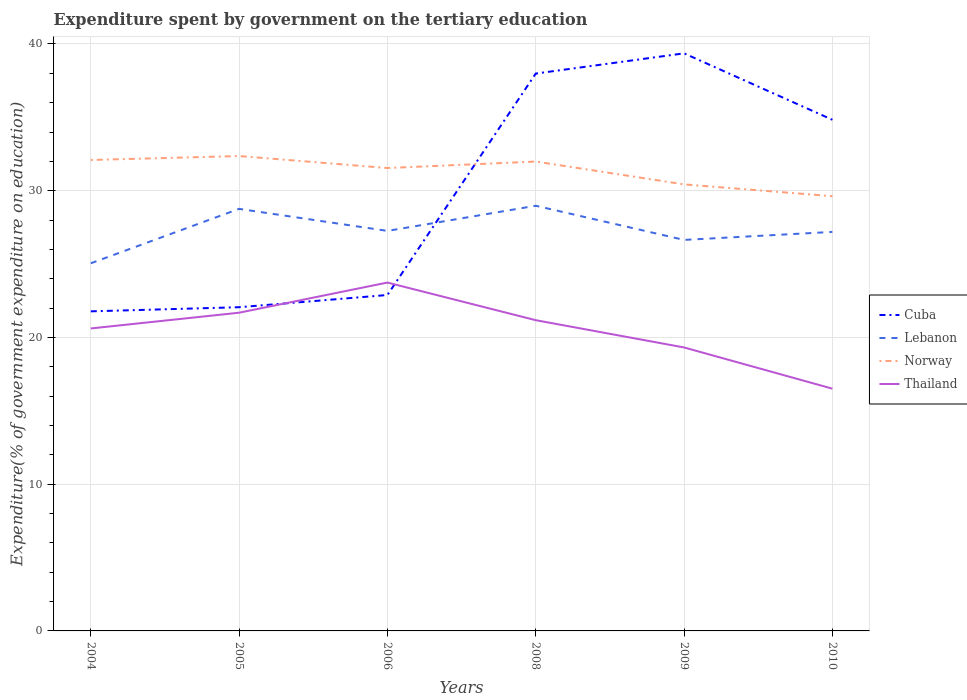Does the line corresponding to Norway intersect with the line corresponding to Cuba?
Ensure brevity in your answer.  Yes. Is the number of lines equal to the number of legend labels?
Keep it short and to the point. Yes. Across all years, what is the maximum expenditure spent by government on the tertiary education in Thailand?
Ensure brevity in your answer.  16.51. In which year was the expenditure spent by government on the tertiary education in Thailand maximum?
Your answer should be compact. 2010. What is the total expenditure spent by government on the tertiary education in Norway in the graph?
Provide a short and direct response. 2.74. What is the difference between the highest and the second highest expenditure spent by government on the tertiary education in Thailand?
Offer a very short reply. 7.23. What is the difference between the highest and the lowest expenditure spent by government on the tertiary education in Cuba?
Give a very brief answer. 3. How many years are there in the graph?
Your answer should be compact. 6. Are the values on the major ticks of Y-axis written in scientific E-notation?
Ensure brevity in your answer.  No. Does the graph contain any zero values?
Offer a terse response. No. Where does the legend appear in the graph?
Make the answer very short. Center right. How many legend labels are there?
Your answer should be compact. 4. How are the legend labels stacked?
Ensure brevity in your answer.  Vertical. What is the title of the graph?
Give a very brief answer. Expenditure spent by government on the tertiary education. What is the label or title of the Y-axis?
Provide a succinct answer. Expenditure(% of government expenditure on education). What is the Expenditure(% of government expenditure on education) of Cuba in 2004?
Keep it short and to the point. 21.78. What is the Expenditure(% of government expenditure on education) of Lebanon in 2004?
Provide a short and direct response. 25.05. What is the Expenditure(% of government expenditure on education) of Norway in 2004?
Provide a short and direct response. 32.09. What is the Expenditure(% of government expenditure on education) of Thailand in 2004?
Provide a short and direct response. 20.61. What is the Expenditure(% of government expenditure on education) in Cuba in 2005?
Your response must be concise. 22.06. What is the Expenditure(% of government expenditure on education) in Lebanon in 2005?
Your answer should be compact. 28.76. What is the Expenditure(% of government expenditure on education) of Norway in 2005?
Your response must be concise. 32.36. What is the Expenditure(% of government expenditure on education) of Thailand in 2005?
Provide a short and direct response. 21.69. What is the Expenditure(% of government expenditure on education) in Cuba in 2006?
Provide a succinct answer. 22.89. What is the Expenditure(% of government expenditure on education) of Lebanon in 2006?
Ensure brevity in your answer.  27.26. What is the Expenditure(% of government expenditure on education) in Norway in 2006?
Offer a terse response. 31.55. What is the Expenditure(% of government expenditure on education) in Thailand in 2006?
Offer a very short reply. 23.74. What is the Expenditure(% of government expenditure on education) in Cuba in 2008?
Your answer should be compact. 37.98. What is the Expenditure(% of government expenditure on education) in Lebanon in 2008?
Your answer should be compact. 28.98. What is the Expenditure(% of government expenditure on education) in Norway in 2008?
Ensure brevity in your answer.  31.99. What is the Expenditure(% of government expenditure on education) of Thailand in 2008?
Your response must be concise. 21.18. What is the Expenditure(% of government expenditure on education) in Cuba in 2009?
Provide a short and direct response. 39.36. What is the Expenditure(% of government expenditure on education) in Lebanon in 2009?
Your response must be concise. 26.65. What is the Expenditure(% of government expenditure on education) of Norway in 2009?
Your answer should be compact. 30.43. What is the Expenditure(% of government expenditure on education) of Thailand in 2009?
Your answer should be very brief. 19.32. What is the Expenditure(% of government expenditure on education) in Cuba in 2010?
Offer a very short reply. 34.83. What is the Expenditure(% of government expenditure on education) in Lebanon in 2010?
Offer a terse response. 27.19. What is the Expenditure(% of government expenditure on education) of Norway in 2010?
Keep it short and to the point. 29.63. What is the Expenditure(% of government expenditure on education) in Thailand in 2010?
Your answer should be compact. 16.51. Across all years, what is the maximum Expenditure(% of government expenditure on education) of Cuba?
Ensure brevity in your answer.  39.36. Across all years, what is the maximum Expenditure(% of government expenditure on education) in Lebanon?
Offer a terse response. 28.98. Across all years, what is the maximum Expenditure(% of government expenditure on education) in Norway?
Make the answer very short. 32.36. Across all years, what is the maximum Expenditure(% of government expenditure on education) in Thailand?
Ensure brevity in your answer.  23.74. Across all years, what is the minimum Expenditure(% of government expenditure on education) of Cuba?
Provide a succinct answer. 21.78. Across all years, what is the minimum Expenditure(% of government expenditure on education) in Lebanon?
Your answer should be compact. 25.05. Across all years, what is the minimum Expenditure(% of government expenditure on education) in Norway?
Your answer should be compact. 29.63. Across all years, what is the minimum Expenditure(% of government expenditure on education) in Thailand?
Provide a short and direct response. 16.51. What is the total Expenditure(% of government expenditure on education) of Cuba in the graph?
Give a very brief answer. 178.91. What is the total Expenditure(% of government expenditure on education) in Lebanon in the graph?
Give a very brief answer. 163.89. What is the total Expenditure(% of government expenditure on education) in Norway in the graph?
Offer a terse response. 188.05. What is the total Expenditure(% of government expenditure on education) in Thailand in the graph?
Offer a very short reply. 123.04. What is the difference between the Expenditure(% of government expenditure on education) of Cuba in 2004 and that in 2005?
Provide a short and direct response. -0.28. What is the difference between the Expenditure(% of government expenditure on education) in Lebanon in 2004 and that in 2005?
Offer a very short reply. -3.71. What is the difference between the Expenditure(% of government expenditure on education) in Norway in 2004 and that in 2005?
Provide a short and direct response. -0.27. What is the difference between the Expenditure(% of government expenditure on education) of Thailand in 2004 and that in 2005?
Provide a short and direct response. -1.07. What is the difference between the Expenditure(% of government expenditure on education) in Cuba in 2004 and that in 2006?
Offer a very short reply. -1.11. What is the difference between the Expenditure(% of government expenditure on education) in Lebanon in 2004 and that in 2006?
Offer a very short reply. -2.21. What is the difference between the Expenditure(% of government expenditure on education) of Norway in 2004 and that in 2006?
Make the answer very short. 0.55. What is the difference between the Expenditure(% of government expenditure on education) in Thailand in 2004 and that in 2006?
Provide a short and direct response. -3.13. What is the difference between the Expenditure(% of government expenditure on education) of Cuba in 2004 and that in 2008?
Ensure brevity in your answer.  -16.21. What is the difference between the Expenditure(% of government expenditure on education) of Lebanon in 2004 and that in 2008?
Give a very brief answer. -3.92. What is the difference between the Expenditure(% of government expenditure on education) of Norway in 2004 and that in 2008?
Provide a short and direct response. 0.11. What is the difference between the Expenditure(% of government expenditure on education) of Thailand in 2004 and that in 2008?
Your answer should be compact. -0.56. What is the difference between the Expenditure(% of government expenditure on education) of Cuba in 2004 and that in 2009?
Your answer should be very brief. -17.58. What is the difference between the Expenditure(% of government expenditure on education) of Lebanon in 2004 and that in 2009?
Offer a very short reply. -1.59. What is the difference between the Expenditure(% of government expenditure on education) of Norway in 2004 and that in 2009?
Offer a terse response. 1.66. What is the difference between the Expenditure(% of government expenditure on education) of Thailand in 2004 and that in 2009?
Your answer should be very brief. 1.29. What is the difference between the Expenditure(% of government expenditure on education) of Cuba in 2004 and that in 2010?
Your answer should be very brief. -13.06. What is the difference between the Expenditure(% of government expenditure on education) of Lebanon in 2004 and that in 2010?
Ensure brevity in your answer.  -2.14. What is the difference between the Expenditure(% of government expenditure on education) in Norway in 2004 and that in 2010?
Keep it short and to the point. 2.47. What is the difference between the Expenditure(% of government expenditure on education) of Thailand in 2004 and that in 2010?
Ensure brevity in your answer.  4.1. What is the difference between the Expenditure(% of government expenditure on education) of Cuba in 2005 and that in 2006?
Offer a very short reply. -0.83. What is the difference between the Expenditure(% of government expenditure on education) in Lebanon in 2005 and that in 2006?
Your answer should be compact. 1.5. What is the difference between the Expenditure(% of government expenditure on education) of Norway in 2005 and that in 2006?
Provide a succinct answer. 0.82. What is the difference between the Expenditure(% of government expenditure on education) in Thailand in 2005 and that in 2006?
Provide a short and direct response. -2.06. What is the difference between the Expenditure(% of government expenditure on education) of Cuba in 2005 and that in 2008?
Give a very brief answer. -15.92. What is the difference between the Expenditure(% of government expenditure on education) in Lebanon in 2005 and that in 2008?
Ensure brevity in your answer.  -0.21. What is the difference between the Expenditure(% of government expenditure on education) in Norway in 2005 and that in 2008?
Your response must be concise. 0.38. What is the difference between the Expenditure(% of government expenditure on education) of Thailand in 2005 and that in 2008?
Keep it short and to the point. 0.51. What is the difference between the Expenditure(% of government expenditure on education) of Cuba in 2005 and that in 2009?
Make the answer very short. -17.3. What is the difference between the Expenditure(% of government expenditure on education) of Lebanon in 2005 and that in 2009?
Offer a terse response. 2.12. What is the difference between the Expenditure(% of government expenditure on education) in Norway in 2005 and that in 2009?
Keep it short and to the point. 1.93. What is the difference between the Expenditure(% of government expenditure on education) of Thailand in 2005 and that in 2009?
Provide a short and direct response. 2.37. What is the difference between the Expenditure(% of government expenditure on education) in Cuba in 2005 and that in 2010?
Your response must be concise. -12.77. What is the difference between the Expenditure(% of government expenditure on education) in Lebanon in 2005 and that in 2010?
Provide a succinct answer. 1.57. What is the difference between the Expenditure(% of government expenditure on education) in Norway in 2005 and that in 2010?
Keep it short and to the point. 2.74. What is the difference between the Expenditure(% of government expenditure on education) in Thailand in 2005 and that in 2010?
Your answer should be compact. 5.18. What is the difference between the Expenditure(% of government expenditure on education) of Cuba in 2006 and that in 2008?
Give a very brief answer. -15.09. What is the difference between the Expenditure(% of government expenditure on education) in Lebanon in 2006 and that in 2008?
Give a very brief answer. -1.71. What is the difference between the Expenditure(% of government expenditure on education) of Norway in 2006 and that in 2008?
Offer a very short reply. -0.44. What is the difference between the Expenditure(% of government expenditure on education) in Thailand in 2006 and that in 2008?
Provide a short and direct response. 2.56. What is the difference between the Expenditure(% of government expenditure on education) in Cuba in 2006 and that in 2009?
Give a very brief answer. -16.47. What is the difference between the Expenditure(% of government expenditure on education) of Lebanon in 2006 and that in 2009?
Keep it short and to the point. 0.61. What is the difference between the Expenditure(% of government expenditure on education) of Norway in 2006 and that in 2009?
Give a very brief answer. 1.11. What is the difference between the Expenditure(% of government expenditure on education) of Thailand in 2006 and that in 2009?
Make the answer very short. 4.42. What is the difference between the Expenditure(% of government expenditure on education) in Cuba in 2006 and that in 2010?
Provide a succinct answer. -11.94. What is the difference between the Expenditure(% of government expenditure on education) of Lebanon in 2006 and that in 2010?
Provide a short and direct response. 0.07. What is the difference between the Expenditure(% of government expenditure on education) in Norway in 2006 and that in 2010?
Offer a very short reply. 1.92. What is the difference between the Expenditure(% of government expenditure on education) in Thailand in 2006 and that in 2010?
Your answer should be very brief. 7.23. What is the difference between the Expenditure(% of government expenditure on education) of Cuba in 2008 and that in 2009?
Provide a succinct answer. -1.38. What is the difference between the Expenditure(% of government expenditure on education) of Lebanon in 2008 and that in 2009?
Ensure brevity in your answer.  2.33. What is the difference between the Expenditure(% of government expenditure on education) of Norway in 2008 and that in 2009?
Provide a short and direct response. 1.56. What is the difference between the Expenditure(% of government expenditure on education) in Thailand in 2008 and that in 2009?
Your response must be concise. 1.86. What is the difference between the Expenditure(% of government expenditure on education) of Cuba in 2008 and that in 2010?
Your response must be concise. 3.15. What is the difference between the Expenditure(% of government expenditure on education) of Lebanon in 2008 and that in 2010?
Your answer should be very brief. 1.78. What is the difference between the Expenditure(% of government expenditure on education) in Norway in 2008 and that in 2010?
Keep it short and to the point. 2.36. What is the difference between the Expenditure(% of government expenditure on education) of Thailand in 2008 and that in 2010?
Keep it short and to the point. 4.67. What is the difference between the Expenditure(% of government expenditure on education) of Cuba in 2009 and that in 2010?
Ensure brevity in your answer.  4.53. What is the difference between the Expenditure(% of government expenditure on education) of Lebanon in 2009 and that in 2010?
Your answer should be very brief. -0.55. What is the difference between the Expenditure(% of government expenditure on education) of Norway in 2009 and that in 2010?
Ensure brevity in your answer.  0.81. What is the difference between the Expenditure(% of government expenditure on education) in Thailand in 2009 and that in 2010?
Make the answer very short. 2.81. What is the difference between the Expenditure(% of government expenditure on education) in Cuba in 2004 and the Expenditure(% of government expenditure on education) in Lebanon in 2005?
Provide a short and direct response. -6.98. What is the difference between the Expenditure(% of government expenditure on education) of Cuba in 2004 and the Expenditure(% of government expenditure on education) of Norway in 2005?
Your answer should be very brief. -10.58. What is the difference between the Expenditure(% of government expenditure on education) of Cuba in 2004 and the Expenditure(% of government expenditure on education) of Thailand in 2005?
Your answer should be compact. 0.09. What is the difference between the Expenditure(% of government expenditure on education) in Lebanon in 2004 and the Expenditure(% of government expenditure on education) in Norway in 2005?
Keep it short and to the point. -7.31. What is the difference between the Expenditure(% of government expenditure on education) of Lebanon in 2004 and the Expenditure(% of government expenditure on education) of Thailand in 2005?
Make the answer very short. 3.37. What is the difference between the Expenditure(% of government expenditure on education) in Norway in 2004 and the Expenditure(% of government expenditure on education) in Thailand in 2005?
Provide a succinct answer. 10.41. What is the difference between the Expenditure(% of government expenditure on education) in Cuba in 2004 and the Expenditure(% of government expenditure on education) in Lebanon in 2006?
Keep it short and to the point. -5.48. What is the difference between the Expenditure(% of government expenditure on education) in Cuba in 2004 and the Expenditure(% of government expenditure on education) in Norway in 2006?
Your response must be concise. -9.77. What is the difference between the Expenditure(% of government expenditure on education) in Cuba in 2004 and the Expenditure(% of government expenditure on education) in Thailand in 2006?
Provide a succinct answer. -1.96. What is the difference between the Expenditure(% of government expenditure on education) in Lebanon in 2004 and the Expenditure(% of government expenditure on education) in Norway in 2006?
Your answer should be very brief. -6.49. What is the difference between the Expenditure(% of government expenditure on education) in Lebanon in 2004 and the Expenditure(% of government expenditure on education) in Thailand in 2006?
Keep it short and to the point. 1.31. What is the difference between the Expenditure(% of government expenditure on education) of Norway in 2004 and the Expenditure(% of government expenditure on education) of Thailand in 2006?
Your answer should be compact. 8.35. What is the difference between the Expenditure(% of government expenditure on education) of Cuba in 2004 and the Expenditure(% of government expenditure on education) of Lebanon in 2008?
Provide a succinct answer. -7.2. What is the difference between the Expenditure(% of government expenditure on education) of Cuba in 2004 and the Expenditure(% of government expenditure on education) of Norway in 2008?
Give a very brief answer. -10.21. What is the difference between the Expenditure(% of government expenditure on education) of Cuba in 2004 and the Expenditure(% of government expenditure on education) of Thailand in 2008?
Keep it short and to the point. 0.6. What is the difference between the Expenditure(% of government expenditure on education) of Lebanon in 2004 and the Expenditure(% of government expenditure on education) of Norway in 2008?
Your answer should be compact. -6.93. What is the difference between the Expenditure(% of government expenditure on education) of Lebanon in 2004 and the Expenditure(% of government expenditure on education) of Thailand in 2008?
Ensure brevity in your answer.  3.88. What is the difference between the Expenditure(% of government expenditure on education) in Norway in 2004 and the Expenditure(% of government expenditure on education) in Thailand in 2008?
Provide a short and direct response. 10.92. What is the difference between the Expenditure(% of government expenditure on education) of Cuba in 2004 and the Expenditure(% of government expenditure on education) of Lebanon in 2009?
Ensure brevity in your answer.  -4.87. What is the difference between the Expenditure(% of government expenditure on education) of Cuba in 2004 and the Expenditure(% of government expenditure on education) of Norway in 2009?
Give a very brief answer. -8.65. What is the difference between the Expenditure(% of government expenditure on education) of Cuba in 2004 and the Expenditure(% of government expenditure on education) of Thailand in 2009?
Give a very brief answer. 2.46. What is the difference between the Expenditure(% of government expenditure on education) in Lebanon in 2004 and the Expenditure(% of government expenditure on education) in Norway in 2009?
Your response must be concise. -5.38. What is the difference between the Expenditure(% of government expenditure on education) in Lebanon in 2004 and the Expenditure(% of government expenditure on education) in Thailand in 2009?
Your answer should be compact. 5.74. What is the difference between the Expenditure(% of government expenditure on education) of Norway in 2004 and the Expenditure(% of government expenditure on education) of Thailand in 2009?
Provide a short and direct response. 12.78. What is the difference between the Expenditure(% of government expenditure on education) in Cuba in 2004 and the Expenditure(% of government expenditure on education) in Lebanon in 2010?
Make the answer very short. -5.41. What is the difference between the Expenditure(% of government expenditure on education) of Cuba in 2004 and the Expenditure(% of government expenditure on education) of Norway in 2010?
Make the answer very short. -7.85. What is the difference between the Expenditure(% of government expenditure on education) of Cuba in 2004 and the Expenditure(% of government expenditure on education) of Thailand in 2010?
Provide a short and direct response. 5.27. What is the difference between the Expenditure(% of government expenditure on education) of Lebanon in 2004 and the Expenditure(% of government expenditure on education) of Norway in 2010?
Keep it short and to the point. -4.57. What is the difference between the Expenditure(% of government expenditure on education) in Lebanon in 2004 and the Expenditure(% of government expenditure on education) in Thailand in 2010?
Make the answer very short. 8.54. What is the difference between the Expenditure(% of government expenditure on education) in Norway in 2004 and the Expenditure(% of government expenditure on education) in Thailand in 2010?
Offer a terse response. 15.58. What is the difference between the Expenditure(% of government expenditure on education) in Cuba in 2005 and the Expenditure(% of government expenditure on education) in Lebanon in 2006?
Give a very brief answer. -5.2. What is the difference between the Expenditure(% of government expenditure on education) of Cuba in 2005 and the Expenditure(% of government expenditure on education) of Norway in 2006?
Provide a succinct answer. -9.48. What is the difference between the Expenditure(% of government expenditure on education) of Cuba in 2005 and the Expenditure(% of government expenditure on education) of Thailand in 2006?
Provide a short and direct response. -1.68. What is the difference between the Expenditure(% of government expenditure on education) of Lebanon in 2005 and the Expenditure(% of government expenditure on education) of Norway in 2006?
Offer a terse response. -2.78. What is the difference between the Expenditure(% of government expenditure on education) in Lebanon in 2005 and the Expenditure(% of government expenditure on education) in Thailand in 2006?
Provide a succinct answer. 5.02. What is the difference between the Expenditure(% of government expenditure on education) of Norway in 2005 and the Expenditure(% of government expenditure on education) of Thailand in 2006?
Your response must be concise. 8.62. What is the difference between the Expenditure(% of government expenditure on education) of Cuba in 2005 and the Expenditure(% of government expenditure on education) of Lebanon in 2008?
Provide a short and direct response. -6.91. What is the difference between the Expenditure(% of government expenditure on education) of Cuba in 2005 and the Expenditure(% of government expenditure on education) of Norway in 2008?
Give a very brief answer. -9.93. What is the difference between the Expenditure(% of government expenditure on education) in Cuba in 2005 and the Expenditure(% of government expenditure on education) in Thailand in 2008?
Give a very brief answer. 0.88. What is the difference between the Expenditure(% of government expenditure on education) of Lebanon in 2005 and the Expenditure(% of government expenditure on education) of Norway in 2008?
Provide a succinct answer. -3.22. What is the difference between the Expenditure(% of government expenditure on education) in Lebanon in 2005 and the Expenditure(% of government expenditure on education) in Thailand in 2008?
Your response must be concise. 7.59. What is the difference between the Expenditure(% of government expenditure on education) of Norway in 2005 and the Expenditure(% of government expenditure on education) of Thailand in 2008?
Your answer should be compact. 11.19. What is the difference between the Expenditure(% of government expenditure on education) in Cuba in 2005 and the Expenditure(% of government expenditure on education) in Lebanon in 2009?
Keep it short and to the point. -4.59. What is the difference between the Expenditure(% of government expenditure on education) of Cuba in 2005 and the Expenditure(% of government expenditure on education) of Norway in 2009?
Your answer should be very brief. -8.37. What is the difference between the Expenditure(% of government expenditure on education) of Cuba in 2005 and the Expenditure(% of government expenditure on education) of Thailand in 2009?
Keep it short and to the point. 2.74. What is the difference between the Expenditure(% of government expenditure on education) in Lebanon in 2005 and the Expenditure(% of government expenditure on education) in Norway in 2009?
Ensure brevity in your answer.  -1.67. What is the difference between the Expenditure(% of government expenditure on education) in Lebanon in 2005 and the Expenditure(% of government expenditure on education) in Thailand in 2009?
Your answer should be very brief. 9.44. What is the difference between the Expenditure(% of government expenditure on education) in Norway in 2005 and the Expenditure(% of government expenditure on education) in Thailand in 2009?
Offer a terse response. 13.04. What is the difference between the Expenditure(% of government expenditure on education) in Cuba in 2005 and the Expenditure(% of government expenditure on education) in Lebanon in 2010?
Your answer should be compact. -5.13. What is the difference between the Expenditure(% of government expenditure on education) in Cuba in 2005 and the Expenditure(% of government expenditure on education) in Norway in 2010?
Ensure brevity in your answer.  -7.57. What is the difference between the Expenditure(% of government expenditure on education) of Cuba in 2005 and the Expenditure(% of government expenditure on education) of Thailand in 2010?
Your answer should be compact. 5.55. What is the difference between the Expenditure(% of government expenditure on education) of Lebanon in 2005 and the Expenditure(% of government expenditure on education) of Norway in 2010?
Provide a short and direct response. -0.86. What is the difference between the Expenditure(% of government expenditure on education) of Lebanon in 2005 and the Expenditure(% of government expenditure on education) of Thailand in 2010?
Give a very brief answer. 12.25. What is the difference between the Expenditure(% of government expenditure on education) of Norway in 2005 and the Expenditure(% of government expenditure on education) of Thailand in 2010?
Provide a succinct answer. 15.85. What is the difference between the Expenditure(% of government expenditure on education) in Cuba in 2006 and the Expenditure(% of government expenditure on education) in Lebanon in 2008?
Your answer should be very brief. -6.08. What is the difference between the Expenditure(% of government expenditure on education) of Cuba in 2006 and the Expenditure(% of government expenditure on education) of Norway in 2008?
Keep it short and to the point. -9.09. What is the difference between the Expenditure(% of government expenditure on education) in Cuba in 2006 and the Expenditure(% of government expenditure on education) in Thailand in 2008?
Provide a short and direct response. 1.72. What is the difference between the Expenditure(% of government expenditure on education) of Lebanon in 2006 and the Expenditure(% of government expenditure on education) of Norway in 2008?
Provide a short and direct response. -4.73. What is the difference between the Expenditure(% of government expenditure on education) in Lebanon in 2006 and the Expenditure(% of government expenditure on education) in Thailand in 2008?
Make the answer very short. 6.08. What is the difference between the Expenditure(% of government expenditure on education) in Norway in 2006 and the Expenditure(% of government expenditure on education) in Thailand in 2008?
Keep it short and to the point. 10.37. What is the difference between the Expenditure(% of government expenditure on education) in Cuba in 2006 and the Expenditure(% of government expenditure on education) in Lebanon in 2009?
Your answer should be very brief. -3.75. What is the difference between the Expenditure(% of government expenditure on education) of Cuba in 2006 and the Expenditure(% of government expenditure on education) of Norway in 2009?
Provide a short and direct response. -7.54. What is the difference between the Expenditure(% of government expenditure on education) in Cuba in 2006 and the Expenditure(% of government expenditure on education) in Thailand in 2009?
Ensure brevity in your answer.  3.57. What is the difference between the Expenditure(% of government expenditure on education) of Lebanon in 2006 and the Expenditure(% of government expenditure on education) of Norway in 2009?
Offer a very short reply. -3.17. What is the difference between the Expenditure(% of government expenditure on education) of Lebanon in 2006 and the Expenditure(% of government expenditure on education) of Thailand in 2009?
Offer a very short reply. 7.94. What is the difference between the Expenditure(% of government expenditure on education) in Norway in 2006 and the Expenditure(% of government expenditure on education) in Thailand in 2009?
Give a very brief answer. 12.23. What is the difference between the Expenditure(% of government expenditure on education) in Cuba in 2006 and the Expenditure(% of government expenditure on education) in Lebanon in 2010?
Provide a short and direct response. -4.3. What is the difference between the Expenditure(% of government expenditure on education) of Cuba in 2006 and the Expenditure(% of government expenditure on education) of Norway in 2010?
Your response must be concise. -6.73. What is the difference between the Expenditure(% of government expenditure on education) in Cuba in 2006 and the Expenditure(% of government expenditure on education) in Thailand in 2010?
Keep it short and to the point. 6.38. What is the difference between the Expenditure(% of government expenditure on education) of Lebanon in 2006 and the Expenditure(% of government expenditure on education) of Norway in 2010?
Provide a short and direct response. -2.37. What is the difference between the Expenditure(% of government expenditure on education) in Lebanon in 2006 and the Expenditure(% of government expenditure on education) in Thailand in 2010?
Your answer should be compact. 10.75. What is the difference between the Expenditure(% of government expenditure on education) of Norway in 2006 and the Expenditure(% of government expenditure on education) of Thailand in 2010?
Make the answer very short. 15.04. What is the difference between the Expenditure(% of government expenditure on education) of Cuba in 2008 and the Expenditure(% of government expenditure on education) of Lebanon in 2009?
Keep it short and to the point. 11.34. What is the difference between the Expenditure(% of government expenditure on education) of Cuba in 2008 and the Expenditure(% of government expenditure on education) of Norway in 2009?
Keep it short and to the point. 7.55. What is the difference between the Expenditure(% of government expenditure on education) of Cuba in 2008 and the Expenditure(% of government expenditure on education) of Thailand in 2009?
Make the answer very short. 18.67. What is the difference between the Expenditure(% of government expenditure on education) of Lebanon in 2008 and the Expenditure(% of government expenditure on education) of Norway in 2009?
Your answer should be compact. -1.46. What is the difference between the Expenditure(% of government expenditure on education) of Lebanon in 2008 and the Expenditure(% of government expenditure on education) of Thailand in 2009?
Make the answer very short. 9.66. What is the difference between the Expenditure(% of government expenditure on education) of Norway in 2008 and the Expenditure(% of government expenditure on education) of Thailand in 2009?
Give a very brief answer. 12.67. What is the difference between the Expenditure(% of government expenditure on education) of Cuba in 2008 and the Expenditure(% of government expenditure on education) of Lebanon in 2010?
Ensure brevity in your answer.  10.79. What is the difference between the Expenditure(% of government expenditure on education) in Cuba in 2008 and the Expenditure(% of government expenditure on education) in Norway in 2010?
Make the answer very short. 8.36. What is the difference between the Expenditure(% of government expenditure on education) in Cuba in 2008 and the Expenditure(% of government expenditure on education) in Thailand in 2010?
Your response must be concise. 21.48. What is the difference between the Expenditure(% of government expenditure on education) of Lebanon in 2008 and the Expenditure(% of government expenditure on education) of Norway in 2010?
Give a very brief answer. -0.65. What is the difference between the Expenditure(% of government expenditure on education) of Lebanon in 2008 and the Expenditure(% of government expenditure on education) of Thailand in 2010?
Give a very brief answer. 12.47. What is the difference between the Expenditure(% of government expenditure on education) of Norway in 2008 and the Expenditure(% of government expenditure on education) of Thailand in 2010?
Offer a terse response. 15.48. What is the difference between the Expenditure(% of government expenditure on education) in Cuba in 2009 and the Expenditure(% of government expenditure on education) in Lebanon in 2010?
Your answer should be very brief. 12.17. What is the difference between the Expenditure(% of government expenditure on education) of Cuba in 2009 and the Expenditure(% of government expenditure on education) of Norway in 2010?
Give a very brief answer. 9.74. What is the difference between the Expenditure(% of government expenditure on education) in Cuba in 2009 and the Expenditure(% of government expenditure on education) in Thailand in 2010?
Make the answer very short. 22.85. What is the difference between the Expenditure(% of government expenditure on education) of Lebanon in 2009 and the Expenditure(% of government expenditure on education) of Norway in 2010?
Provide a short and direct response. -2.98. What is the difference between the Expenditure(% of government expenditure on education) in Lebanon in 2009 and the Expenditure(% of government expenditure on education) in Thailand in 2010?
Your answer should be compact. 10.14. What is the difference between the Expenditure(% of government expenditure on education) of Norway in 2009 and the Expenditure(% of government expenditure on education) of Thailand in 2010?
Your answer should be very brief. 13.92. What is the average Expenditure(% of government expenditure on education) of Cuba per year?
Ensure brevity in your answer.  29.82. What is the average Expenditure(% of government expenditure on education) in Lebanon per year?
Provide a succinct answer. 27.32. What is the average Expenditure(% of government expenditure on education) in Norway per year?
Provide a succinct answer. 31.34. What is the average Expenditure(% of government expenditure on education) in Thailand per year?
Give a very brief answer. 20.51. In the year 2004, what is the difference between the Expenditure(% of government expenditure on education) of Cuba and Expenditure(% of government expenditure on education) of Lebanon?
Keep it short and to the point. -3.28. In the year 2004, what is the difference between the Expenditure(% of government expenditure on education) of Cuba and Expenditure(% of government expenditure on education) of Norway?
Your answer should be compact. -10.32. In the year 2004, what is the difference between the Expenditure(% of government expenditure on education) of Cuba and Expenditure(% of government expenditure on education) of Thailand?
Your answer should be very brief. 1.17. In the year 2004, what is the difference between the Expenditure(% of government expenditure on education) in Lebanon and Expenditure(% of government expenditure on education) in Norway?
Offer a terse response. -7.04. In the year 2004, what is the difference between the Expenditure(% of government expenditure on education) in Lebanon and Expenditure(% of government expenditure on education) in Thailand?
Keep it short and to the point. 4.44. In the year 2004, what is the difference between the Expenditure(% of government expenditure on education) of Norway and Expenditure(% of government expenditure on education) of Thailand?
Provide a short and direct response. 11.48. In the year 2005, what is the difference between the Expenditure(% of government expenditure on education) in Cuba and Expenditure(% of government expenditure on education) in Lebanon?
Make the answer very short. -6.7. In the year 2005, what is the difference between the Expenditure(% of government expenditure on education) in Cuba and Expenditure(% of government expenditure on education) in Norway?
Offer a terse response. -10.3. In the year 2005, what is the difference between the Expenditure(% of government expenditure on education) of Cuba and Expenditure(% of government expenditure on education) of Thailand?
Your answer should be very brief. 0.38. In the year 2005, what is the difference between the Expenditure(% of government expenditure on education) of Lebanon and Expenditure(% of government expenditure on education) of Norway?
Provide a short and direct response. -3.6. In the year 2005, what is the difference between the Expenditure(% of government expenditure on education) in Lebanon and Expenditure(% of government expenditure on education) in Thailand?
Offer a very short reply. 7.08. In the year 2005, what is the difference between the Expenditure(% of government expenditure on education) in Norway and Expenditure(% of government expenditure on education) in Thailand?
Offer a very short reply. 10.68. In the year 2006, what is the difference between the Expenditure(% of government expenditure on education) in Cuba and Expenditure(% of government expenditure on education) in Lebanon?
Ensure brevity in your answer.  -4.37. In the year 2006, what is the difference between the Expenditure(% of government expenditure on education) of Cuba and Expenditure(% of government expenditure on education) of Norway?
Provide a short and direct response. -8.65. In the year 2006, what is the difference between the Expenditure(% of government expenditure on education) of Cuba and Expenditure(% of government expenditure on education) of Thailand?
Offer a very short reply. -0.85. In the year 2006, what is the difference between the Expenditure(% of government expenditure on education) of Lebanon and Expenditure(% of government expenditure on education) of Norway?
Offer a terse response. -4.28. In the year 2006, what is the difference between the Expenditure(% of government expenditure on education) in Lebanon and Expenditure(% of government expenditure on education) in Thailand?
Give a very brief answer. 3.52. In the year 2006, what is the difference between the Expenditure(% of government expenditure on education) in Norway and Expenditure(% of government expenditure on education) in Thailand?
Give a very brief answer. 7.8. In the year 2008, what is the difference between the Expenditure(% of government expenditure on education) of Cuba and Expenditure(% of government expenditure on education) of Lebanon?
Your response must be concise. 9.01. In the year 2008, what is the difference between the Expenditure(% of government expenditure on education) of Cuba and Expenditure(% of government expenditure on education) of Norway?
Offer a terse response. 6. In the year 2008, what is the difference between the Expenditure(% of government expenditure on education) of Cuba and Expenditure(% of government expenditure on education) of Thailand?
Keep it short and to the point. 16.81. In the year 2008, what is the difference between the Expenditure(% of government expenditure on education) of Lebanon and Expenditure(% of government expenditure on education) of Norway?
Provide a short and direct response. -3.01. In the year 2008, what is the difference between the Expenditure(% of government expenditure on education) in Lebanon and Expenditure(% of government expenditure on education) in Thailand?
Make the answer very short. 7.8. In the year 2008, what is the difference between the Expenditure(% of government expenditure on education) in Norway and Expenditure(% of government expenditure on education) in Thailand?
Ensure brevity in your answer.  10.81. In the year 2009, what is the difference between the Expenditure(% of government expenditure on education) of Cuba and Expenditure(% of government expenditure on education) of Lebanon?
Keep it short and to the point. 12.71. In the year 2009, what is the difference between the Expenditure(% of government expenditure on education) in Cuba and Expenditure(% of government expenditure on education) in Norway?
Your answer should be compact. 8.93. In the year 2009, what is the difference between the Expenditure(% of government expenditure on education) of Cuba and Expenditure(% of government expenditure on education) of Thailand?
Provide a succinct answer. 20.04. In the year 2009, what is the difference between the Expenditure(% of government expenditure on education) in Lebanon and Expenditure(% of government expenditure on education) in Norway?
Make the answer very short. -3.79. In the year 2009, what is the difference between the Expenditure(% of government expenditure on education) in Lebanon and Expenditure(% of government expenditure on education) in Thailand?
Keep it short and to the point. 7.33. In the year 2009, what is the difference between the Expenditure(% of government expenditure on education) of Norway and Expenditure(% of government expenditure on education) of Thailand?
Your answer should be compact. 11.11. In the year 2010, what is the difference between the Expenditure(% of government expenditure on education) of Cuba and Expenditure(% of government expenditure on education) of Lebanon?
Ensure brevity in your answer.  7.64. In the year 2010, what is the difference between the Expenditure(% of government expenditure on education) in Cuba and Expenditure(% of government expenditure on education) in Norway?
Provide a short and direct response. 5.21. In the year 2010, what is the difference between the Expenditure(% of government expenditure on education) in Cuba and Expenditure(% of government expenditure on education) in Thailand?
Provide a succinct answer. 18.32. In the year 2010, what is the difference between the Expenditure(% of government expenditure on education) of Lebanon and Expenditure(% of government expenditure on education) of Norway?
Make the answer very short. -2.43. In the year 2010, what is the difference between the Expenditure(% of government expenditure on education) of Lebanon and Expenditure(% of government expenditure on education) of Thailand?
Provide a succinct answer. 10.68. In the year 2010, what is the difference between the Expenditure(% of government expenditure on education) of Norway and Expenditure(% of government expenditure on education) of Thailand?
Your answer should be very brief. 13.12. What is the ratio of the Expenditure(% of government expenditure on education) in Cuba in 2004 to that in 2005?
Offer a terse response. 0.99. What is the ratio of the Expenditure(% of government expenditure on education) in Lebanon in 2004 to that in 2005?
Make the answer very short. 0.87. What is the ratio of the Expenditure(% of government expenditure on education) of Thailand in 2004 to that in 2005?
Offer a terse response. 0.95. What is the ratio of the Expenditure(% of government expenditure on education) in Cuba in 2004 to that in 2006?
Make the answer very short. 0.95. What is the ratio of the Expenditure(% of government expenditure on education) of Lebanon in 2004 to that in 2006?
Provide a short and direct response. 0.92. What is the ratio of the Expenditure(% of government expenditure on education) of Norway in 2004 to that in 2006?
Offer a terse response. 1.02. What is the ratio of the Expenditure(% of government expenditure on education) of Thailand in 2004 to that in 2006?
Offer a very short reply. 0.87. What is the ratio of the Expenditure(% of government expenditure on education) in Cuba in 2004 to that in 2008?
Provide a succinct answer. 0.57. What is the ratio of the Expenditure(% of government expenditure on education) of Lebanon in 2004 to that in 2008?
Ensure brevity in your answer.  0.86. What is the ratio of the Expenditure(% of government expenditure on education) in Thailand in 2004 to that in 2008?
Ensure brevity in your answer.  0.97. What is the ratio of the Expenditure(% of government expenditure on education) of Cuba in 2004 to that in 2009?
Provide a short and direct response. 0.55. What is the ratio of the Expenditure(% of government expenditure on education) of Lebanon in 2004 to that in 2009?
Your response must be concise. 0.94. What is the ratio of the Expenditure(% of government expenditure on education) of Norway in 2004 to that in 2009?
Ensure brevity in your answer.  1.05. What is the ratio of the Expenditure(% of government expenditure on education) of Thailand in 2004 to that in 2009?
Ensure brevity in your answer.  1.07. What is the ratio of the Expenditure(% of government expenditure on education) of Cuba in 2004 to that in 2010?
Offer a very short reply. 0.63. What is the ratio of the Expenditure(% of government expenditure on education) of Lebanon in 2004 to that in 2010?
Keep it short and to the point. 0.92. What is the ratio of the Expenditure(% of government expenditure on education) in Thailand in 2004 to that in 2010?
Your answer should be compact. 1.25. What is the ratio of the Expenditure(% of government expenditure on education) in Cuba in 2005 to that in 2006?
Offer a very short reply. 0.96. What is the ratio of the Expenditure(% of government expenditure on education) in Lebanon in 2005 to that in 2006?
Give a very brief answer. 1.06. What is the ratio of the Expenditure(% of government expenditure on education) of Norway in 2005 to that in 2006?
Ensure brevity in your answer.  1.03. What is the ratio of the Expenditure(% of government expenditure on education) of Thailand in 2005 to that in 2006?
Offer a very short reply. 0.91. What is the ratio of the Expenditure(% of government expenditure on education) in Cuba in 2005 to that in 2008?
Your answer should be very brief. 0.58. What is the ratio of the Expenditure(% of government expenditure on education) of Norway in 2005 to that in 2008?
Your answer should be compact. 1.01. What is the ratio of the Expenditure(% of government expenditure on education) in Thailand in 2005 to that in 2008?
Provide a succinct answer. 1.02. What is the ratio of the Expenditure(% of government expenditure on education) in Cuba in 2005 to that in 2009?
Provide a short and direct response. 0.56. What is the ratio of the Expenditure(% of government expenditure on education) of Lebanon in 2005 to that in 2009?
Provide a short and direct response. 1.08. What is the ratio of the Expenditure(% of government expenditure on education) in Norway in 2005 to that in 2009?
Offer a terse response. 1.06. What is the ratio of the Expenditure(% of government expenditure on education) of Thailand in 2005 to that in 2009?
Provide a succinct answer. 1.12. What is the ratio of the Expenditure(% of government expenditure on education) in Cuba in 2005 to that in 2010?
Give a very brief answer. 0.63. What is the ratio of the Expenditure(% of government expenditure on education) of Lebanon in 2005 to that in 2010?
Offer a terse response. 1.06. What is the ratio of the Expenditure(% of government expenditure on education) in Norway in 2005 to that in 2010?
Offer a terse response. 1.09. What is the ratio of the Expenditure(% of government expenditure on education) of Thailand in 2005 to that in 2010?
Ensure brevity in your answer.  1.31. What is the ratio of the Expenditure(% of government expenditure on education) of Cuba in 2006 to that in 2008?
Your answer should be compact. 0.6. What is the ratio of the Expenditure(% of government expenditure on education) of Lebanon in 2006 to that in 2008?
Provide a short and direct response. 0.94. What is the ratio of the Expenditure(% of government expenditure on education) of Norway in 2006 to that in 2008?
Keep it short and to the point. 0.99. What is the ratio of the Expenditure(% of government expenditure on education) of Thailand in 2006 to that in 2008?
Keep it short and to the point. 1.12. What is the ratio of the Expenditure(% of government expenditure on education) in Cuba in 2006 to that in 2009?
Give a very brief answer. 0.58. What is the ratio of the Expenditure(% of government expenditure on education) of Norway in 2006 to that in 2009?
Your answer should be very brief. 1.04. What is the ratio of the Expenditure(% of government expenditure on education) of Thailand in 2006 to that in 2009?
Provide a succinct answer. 1.23. What is the ratio of the Expenditure(% of government expenditure on education) of Cuba in 2006 to that in 2010?
Make the answer very short. 0.66. What is the ratio of the Expenditure(% of government expenditure on education) of Lebanon in 2006 to that in 2010?
Keep it short and to the point. 1. What is the ratio of the Expenditure(% of government expenditure on education) of Norway in 2006 to that in 2010?
Provide a short and direct response. 1.06. What is the ratio of the Expenditure(% of government expenditure on education) in Thailand in 2006 to that in 2010?
Ensure brevity in your answer.  1.44. What is the ratio of the Expenditure(% of government expenditure on education) in Cuba in 2008 to that in 2009?
Provide a succinct answer. 0.96. What is the ratio of the Expenditure(% of government expenditure on education) in Lebanon in 2008 to that in 2009?
Give a very brief answer. 1.09. What is the ratio of the Expenditure(% of government expenditure on education) in Norway in 2008 to that in 2009?
Your answer should be very brief. 1.05. What is the ratio of the Expenditure(% of government expenditure on education) of Thailand in 2008 to that in 2009?
Give a very brief answer. 1.1. What is the ratio of the Expenditure(% of government expenditure on education) of Cuba in 2008 to that in 2010?
Make the answer very short. 1.09. What is the ratio of the Expenditure(% of government expenditure on education) in Lebanon in 2008 to that in 2010?
Your answer should be very brief. 1.07. What is the ratio of the Expenditure(% of government expenditure on education) of Norway in 2008 to that in 2010?
Provide a short and direct response. 1.08. What is the ratio of the Expenditure(% of government expenditure on education) of Thailand in 2008 to that in 2010?
Give a very brief answer. 1.28. What is the ratio of the Expenditure(% of government expenditure on education) in Cuba in 2009 to that in 2010?
Offer a terse response. 1.13. What is the ratio of the Expenditure(% of government expenditure on education) in Lebanon in 2009 to that in 2010?
Give a very brief answer. 0.98. What is the ratio of the Expenditure(% of government expenditure on education) of Norway in 2009 to that in 2010?
Ensure brevity in your answer.  1.03. What is the ratio of the Expenditure(% of government expenditure on education) of Thailand in 2009 to that in 2010?
Provide a succinct answer. 1.17. What is the difference between the highest and the second highest Expenditure(% of government expenditure on education) in Cuba?
Your response must be concise. 1.38. What is the difference between the highest and the second highest Expenditure(% of government expenditure on education) of Lebanon?
Keep it short and to the point. 0.21. What is the difference between the highest and the second highest Expenditure(% of government expenditure on education) of Norway?
Make the answer very short. 0.27. What is the difference between the highest and the second highest Expenditure(% of government expenditure on education) of Thailand?
Your answer should be very brief. 2.06. What is the difference between the highest and the lowest Expenditure(% of government expenditure on education) in Cuba?
Offer a very short reply. 17.58. What is the difference between the highest and the lowest Expenditure(% of government expenditure on education) in Lebanon?
Provide a succinct answer. 3.92. What is the difference between the highest and the lowest Expenditure(% of government expenditure on education) of Norway?
Keep it short and to the point. 2.74. What is the difference between the highest and the lowest Expenditure(% of government expenditure on education) of Thailand?
Provide a succinct answer. 7.23. 